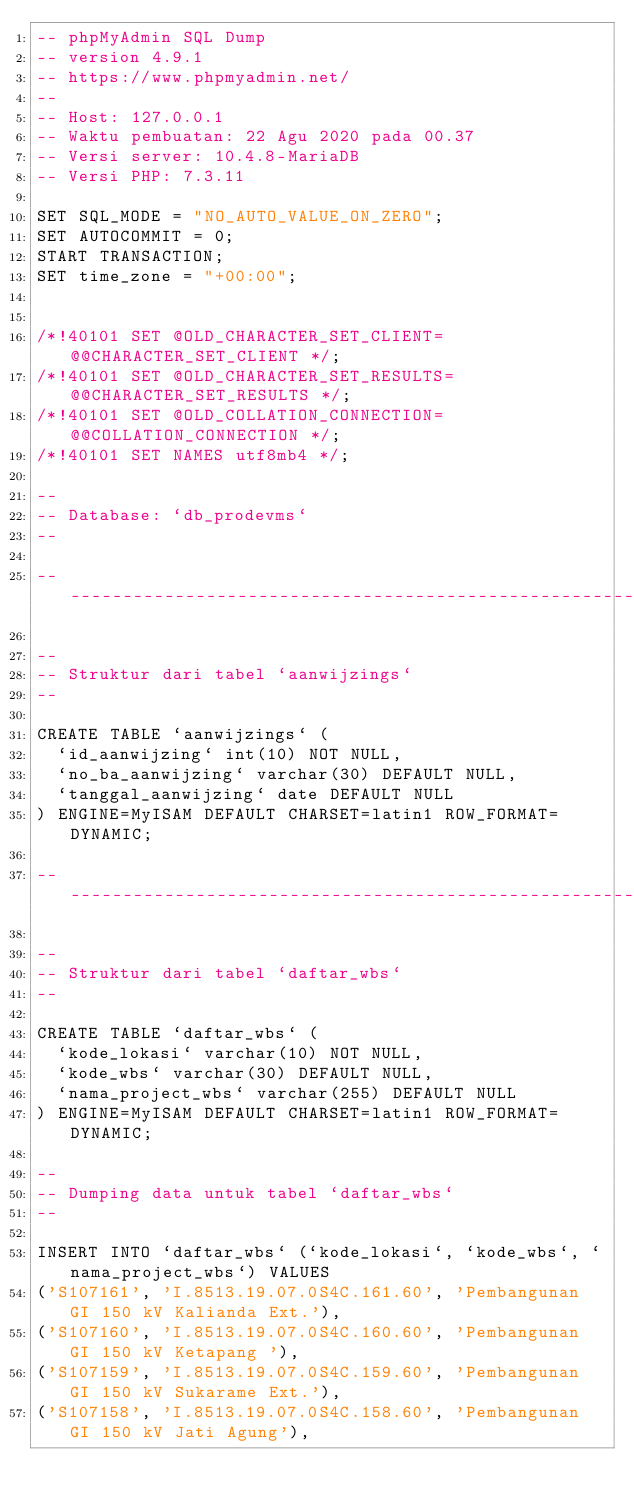Convert code to text. <code><loc_0><loc_0><loc_500><loc_500><_SQL_>-- phpMyAdmin SQL Dump
-- version 4.9.1
-- https://www.phpmyadmin.net/
--
-- Host: 127.0.0.1
-- Waktu pembuatan: 22 Agu 2020 pada 00.37
-- Versi server: 10.4.8-MariaDB
-- Versi PHP: 7.3.11

SET SQL_MODE = "NO_AUTO_VALUE_ON_ZERO";
SET AUTOCOMMIT = 0;
START TRANSACTION;
SET time_zone = "+00:00";


/*!40101 SET @OLD_CHARACTER_SET_CLIENT=@@CHARACTER_SET_CLIENT */;
/*!40101 SET @OLD_CHARACTER_SET_RESULTS=@@CHARACTER_SET_RESULTS */;
/*!40101 SET @OLD_COLLATION_CONNECTION=@@COLLATION_CONNECTION */;
/*!40101 SET NAMES utf8mb4 */;

--
-- Database: `db_prodevms`
--

-- --------------------------------------------------------

--
-- Struktur dari tabel `aanwijzings`
--

CREATE TABLE `aanwijzings` (
  `id_aanwijzing` int(10) NOT NULL,
  `no_ba_aanwijzing` varchar(30) DEFAULT NULL,
  `tanggal_aanwijzing` date DEFAULT NULL
) ENGINE=MyISAM DEFAULT CHARSET=latin1 ROW_FORMAT=DYNAMIC;

-- --------------------------------------------------------

--
-- Struktur dari tabel `daftar_wbs`
--

CREATE TABLE `daftar_wbs` (
  `kode_lokasi` varchar(10) NOT NULL,
  `kode_wbs` varchar(30) DEFAULT NULL,
  `nama_project_wbs` varchar(255) DEFAULT NULL
) ENGINE=MyISAM DEFAULT CHARSET=latin1 ROW_FORMAT=DYNAMIC;

--
-- Dumping data untuk tabel `daftar_wbs`
--

INSERT INTO `daftar_wbs` (`kode_lokasi`, `kode_wbs`, `nama_project_wbs`) VALUES
('S107161', 'I.8513.19.07.0S4C.161.60', 'Pembangunan GI 150 kV Kalianda Ext.'),
('S107160', 'I.8513.19.07.0S4C.160.60', 'Pembangunan GI 150 kV Ketapang '),
('S107159', 'I.8513.19.07.0S4C.159.60', 'Pembangunan GI 150 kV Sukarame Ext.'),
('S107158', 'I.8513.19.07.0S4C.158.60', 'Pembangunan GI 150 kV Jati Agung'),</code> 